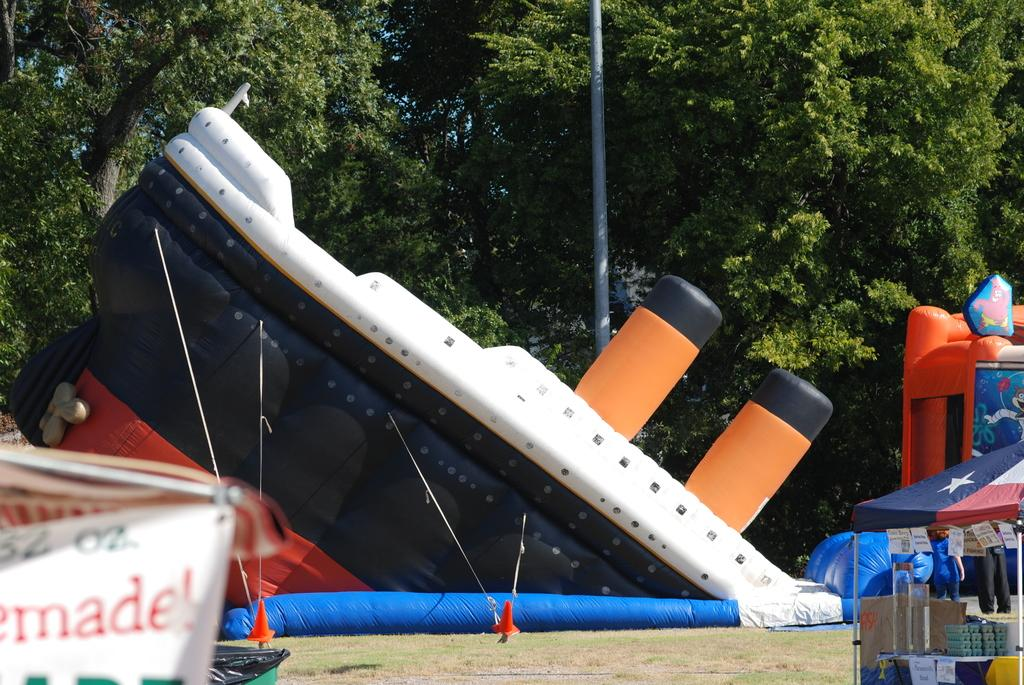What type of objects can be seen in the image? There are inflatable objects in the image. Are there any natural elements visible in the image? Yes, trees are present at the top side of the image. What type of ray can be seen swimming in the image? There is no ray present in the image; it features inflatable objects and trees. What type of wound is visible on the inflatable object in the image? There is no wound visible on the inflatable objects in the image. 